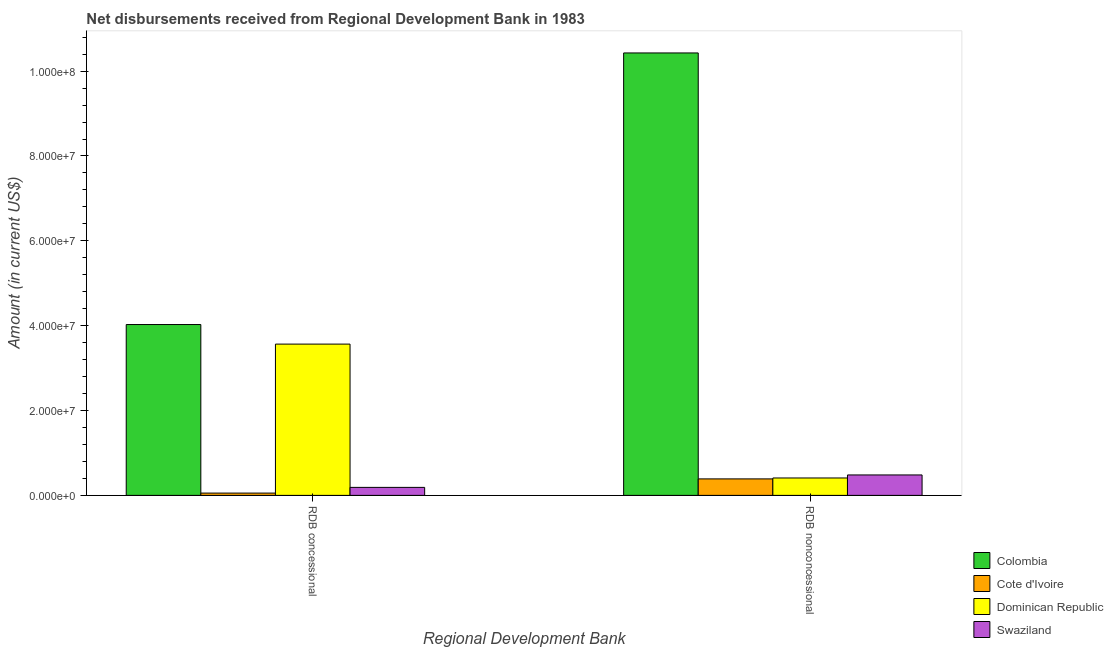How many different coloured bars are there?
Offer a very short reply. 4. What is the label of the 2nd group of bars from the left?
Your answer should be very brief. RDB nonconcessional. What is the net concessional disbursements from rdb in Colombia?
Your answer should be compact. 4.03e+07. Across all countries, what is the maximum net non concessional disbursements from rdb?
Keep it short and to the point. 1.04e+08. Across all countries, what is the minimum net concessional disbursements from rdb?
Give a very brief answer. 5.43e+05. In which country was the net concessional disbursements from rdb minimum?
Provide a short and direct response. Cote d'Ivoire. What is the total net concessional disbursements from rdb in the graph?
Your answer should be very brief. 7.84e+07. What is the difference between the net concessional disbursements from rdb in Colombia and that in Swaziland?
Keep it short and to the point. 3.84e+07. What is the difference between the net non concessional disbursements from rdb in Swaziland and the net concessional disbursements from rdb in Colombia?
Ensure brevity in your answer.  -3.55e+07. What is the average net non concessional disbursements from rdb per country?
Provide a short and direct response. 2.93e+07. What is the difference between the net non concessional disbursements from rdb and net concessional disbursements from rdb in Cote d'Ivoire?
Offer a terse response. 3.34e+06. What is the ratio of the net concessional disbursements from rdb in Swaziland to that in Colombia?
Provide a short and direct response. 0.05. In how many countries, is the net concessional disbursements from rdb greater than the average net concessional disbursements from rdb taken over all countries?
Ensure brevity in your answer.  2. What does the 4th bar from the left in RDB concessional represents?
Offer a very short reply. Swaziland. What does the 3rd bar from the right in RDB concessional represents?
Ensure brevity in your answer.  Cote d'Ivoire. How many countries are there in the graph?
Make the answer very short. 4. Does the graph contain any zero values?
Your response must be concise. No. Does the graph contain grids?
Your response must be concise. No. How many legend labels are there?
Your answer should be compact. 4. How are the legend labels stacked?
Your answer should be compact. Vertical. What is the title of the graph?
Your response must be concise. Net disbursements received from Regional Development Bank in 1983. Does "Micronesia" appear as one of the legend labels in the graph?
Make the answer very short. No. What is the label or title of the X-axis?
Provide a succinct answer. Regional Development Bank. What is the Amount (in current US$) of Colombia in RDB concessional?
Keep it short and to the point. 4.03e+07. What is the Amount (in current US$) in Cote d'Ivoire in RDB concessional?
Ensure brevity in your answer.  5.43e+05. What is the Amount (in current US$) in Dominican Republic in RDB concessional?
Your answer should be very brief. 3.57e+07. What is the Amount (in current US$) in Swaziland in RDB concessional?
Offer a terse response. 1.89e+06. What is the Amount (in current US$) in Colombia in RDB nonconcessional?
Offer a terse response. 1.04e+08. What is the Amount (in current US$) in Cote d'Ivoire in RDB nonconcessional?
Provide a succinct answer. 3.89e+06. What is the Amount (in current US$) in Dominican Republic in RDB nonconcessional?
Give a very brief answer. 4.10e+06. What is the Amount (in current US$) in Swaziland in RDB nonconcessional?
Offer a very short reply. 4.82e+06. Across all Regional Development Bank, what is the maximum Amount (in current US$) of Colombia?
Offer a terse response. 1.04e+08. Across all Regional Development Bank, what is the maximum Amount (in current US$) in Cote d'Ivoire?
Keep it short and to the point. 3.89e+06. Across all Regional Development Bank, what is the maximum Amount (in current US$) in Dominican Republic?
Ensure brevity in your answer.  3.57e+07. Across all Regional Development Bank, what is the maximum Amount (in current US$) in Swaziland?
Your answer should be compact. 4.82e+06. Across all Regional Development Bank, what is the minimum Amount (in current US$) of Colombia?
Offer a very short reply. 4.03e+07. Across all Regional Development Bank, what is the minimum Amount (in current US$) of Cote d'Ivoire?
Offer a terse response. 5.43e+05. Across all Regional Development Bank, what is the minimum Amount (in current US$) in Dominican Republic?
Provide a succinct answer. 4.10e+06. Across all Regional Development Bank, what is the minimum Amount (in current US$) in Swaziland?
Offer a very short reply. 1.89e+06. What is the total Amount (in current US$) of Colombia in the graph?
Your response must be concise. 1.45e+08. What is the total Amount (in current US$) in Cote d'Ivoire in the graph?
Your answer should be compact. 4.43e+06. What is the total Amount (in current US$) of Dominican Republic in the graph?
Offer a terse response. 3.98e+07. What is the total Amount (in current US$) of Swaziland in the graph?
Offer a terse response. 6.70e+06. What is the difference between the Amount (in current US$) in Colombia in RDB concessional and that in RDB nonconcessional?
Keep it short and to the point. -6.40e+07. What is the difference between the Amount (in current US$) of Cote d'Ivoire in RDB concessional and that in RDB nonconcessional?
Offer a terse response. -3.34e+06. What is the difference between the Amount (in current US$) in Dominican Republic in RDB concessional and that in RDB nonconcessional?
Give a very brief answer. 3.16e+07. What is the difference between the Amount (in current US$) in Swaziland in RDB concessional and that in RDB nonconcessional?
Provide a succinct answer. -2.93e+06. What is the difference between the Amount (in current US$) in Colombia in RDB concessional and the Amount (in current US$) in Cote d'Ivoire in RDB nonconcessional?
Make the answer very short. 3.64e+07. What is the difference between the Amount (in current US$) in Colombia in RDB concessional and the Amount (in current US$) in Dominican Republic in RDB nonconcessional?
Your answer should be very brief. 3.62e+07. What is the difference between the Amount (in current US$) in Colombia in RDB concessional and the Amount (in current US$) in Swaziland in RDB nonconcessional?
Give a very brief answer. 3.55e+07. What is the difference between the Amount (in current US$) of Cote d'Ivoire in RDB concessional and the Amount (in current US$) of Dominican Republic in RDB nonconcessional?
Offer a very short reply. -3.56e+06. What is the difference between the Amount (in current US$) in Cote d'Ivoire in RDB concessional and the Amount (in current US$) in Swaziland in RDB nonconcessional?
Provide a succinct answer. -4.28e+06. What is the difference between the Amount (in current US$) in Dominican Republic in RDB concessional and the Amount (in current US$) in Swaziland in RDB nonconcessional?
Give a very brief answer. 3.08e+07. What is the average Amount (in current US$) in Colombia per Regional Development Bank?
Provide a short and direct response. 7.23e+07. What is the average Amount (in current US$) of Cote d'Ivoire per Regional Development Bank?
Give a very brief answer. 2.22e+06. What is the average Amount (in current US$) of Dominican Republic per Regional Development Bank?
Give a very brief answer. 1.99e+07. What is the average Amount (in current US$) of Swaziland per Regional Development Bank?
Give a very brief answer. 3.35e+06. What is the difference between the Amount (in current US$) of Colombia and Amount (in current US$) of Cote d'Ivoire in RDB concessional?
Provide a succinct answer. 3.97e+07. What is the difference between the Amount (in current US$) in Colombia and Amount (in current US$) in Dominican Republic in RDB concessional?
Give a very brief answer. 4.61e+06. What is the difference between the Amount (in current US$) of Colombia and Amount (in current US$) of Swaziland in RDB concessional?
Your answer should be compact. 3.84e+07. What is the difference between the Amount (in current US$) of Cote d'Ivoire and Amount (in current US$) of Dominican Republic in RDB concessional?
Provide a short and direct response. -3.51e+07. What is the difference between the Amount (in current US$) of Cote d'Ivoire and Amount (in current US$) of Swaziland in RDB concessional?
Keep it short and to the point. -1.34e+06. What is the difference between the Amount (in current US$) of Dominican Republic and Amount (in current US$) of Swaziland in RDB concessional?
Provide a short and direct response. 3.38e+07. What is the difference between the Amount (in current US$) of Colombia and Amount (in current US$) of Cote d'Ivoire in RDB nonconcessional?
Offer a very short reply. 1.00e+08. What is the difference between the Amount (in current US$) in Colombia and Amount (in current US$) in Dominican Republic in RDB nonconcessional?
Offer a terse response. 1.00e+08. What is the difference between the Amount (in current US$) in Colombia and Amount (in current US$) in Swaziland in RDB nonconcessional?
Provide a succinct answer. 9.95e+07. What is the difference between the Amount (in current US$) in Cote d'Ivoire and Amount (in current US$) in Dominican Republic in RDB nonconcessional?
Your answer should be compact. -2.15e+05. What is the difference between the Amount (in current US$) in Cote d'Ivoire and Amount (in current US$) in Swaziland in RDB nonconcessional?
Provide a short and direct response. -9.30e+05. What is the difference between the Amount (in current US$) of Dominican Republic and Amount (in current US$) of Swaziland in RDB nonconcessional?
Give a very brief answer. -7.15e+05. What is the ratio of the Amount (in current US$) in Colombia in RDB concessional to that in RDB nonconcessional?
Keep it short and to the point. 0.39. What is the ratio of the Amount (in current US$) of Cote d'Ivoire in RDB concessional to that in RDB nonconcessional?
Your response must be concise. 0.14. What is the ratio of the Amount (in current US$) of Dominican Republic in RDB concessional to that in RDB nonconcessional?
Your response must be concise. 8.69. What is the ratio of the Amount (in current US$) in Swaziland in RDB concessional to that in RDB nonconcessional?
Keep it short and to the point. 0.39. What is the difference between the highest and the second highest Amount (in current US$) of Colombia?
Give a very brief answer. 6.40e+07. What is the difference between the highest and the second highest Amount (in current US$) in Cote d'Ivoire?
Keep it short and to the point. 3.34e+06. What is the difference between the highest and the second highest Amount (in current US$) of Dominican Republic?
Ensure brevity in your answer.  3.16e+07. What is the difference between the highest and the second highest Amount (in current US$) of Swaziland?
Your answer should be very brief. 2.93e+06. What is the difference between the highest and the lowest Amount (in current US$) in Colombia?
Provide a succinct answer. 6.40e+07. What is the difference between the highest and the lowest Amount (in current US$) in Cote d'Ivoire?
Provide a short and direct response. 3.34e+06. What is the difference between the highest and the lowest Amount (in current US$) of Dominican Republic?
Your answer should be very brief. 3.16e+07. What is the difference between the highest and the lowest Amount (in current US$) of Swaziland?
Offer a terse response. 2.93e+06. 